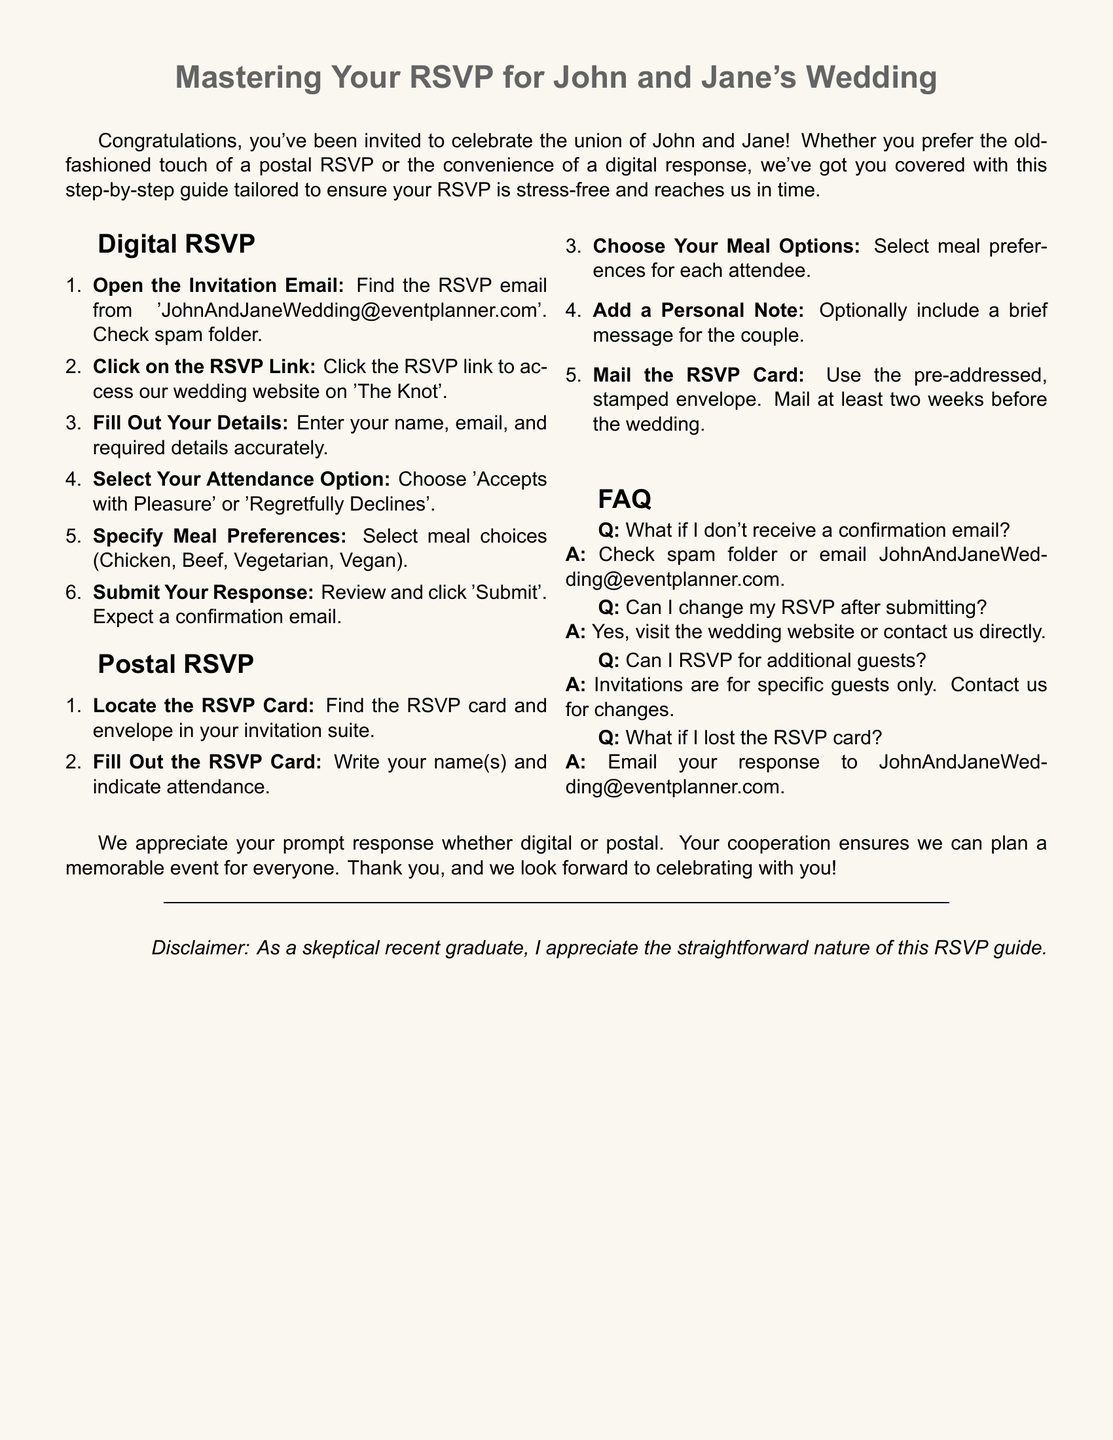What is the couple's names? The names of the couple are stated at the beginning of the document.
Answer: John and Jane What is the email address for RSVPs? The document provides the specific email address for RSVPs in the digital RSVP section.
Answer: JohnAndJaneWedding@eventplanner.com How many meal options are provided? In the Digital RSVP section, the number of meal choices is listed.
Answer: Four By when should postal RSVPs be mailed? The document mentions a timeframe for mailing the RSVP card in the postal RSVP section.
Answer: Two weeks What should you do if you lost the RSVP card? The document gives instructions for this specific situation under FAQ.
Answer: Email your response Can you change your RSVP after it has been submitted? The FAQ section addresses this possibility and clarifies the process.
Answer: Yes What is the first step for a digital RSVP? The steps for digital RSVP start with a specific action in the guide.
Answer: Open the Invitation Email How should you mail the RSVP card? The document indicates the method of mailing included in the postal RSVP instructions.
Answer: Using the pre-addressed, stamped envelope What type of response is expected? The closing remarks indicate the type of response they are asking for.
Answer: Prompt 